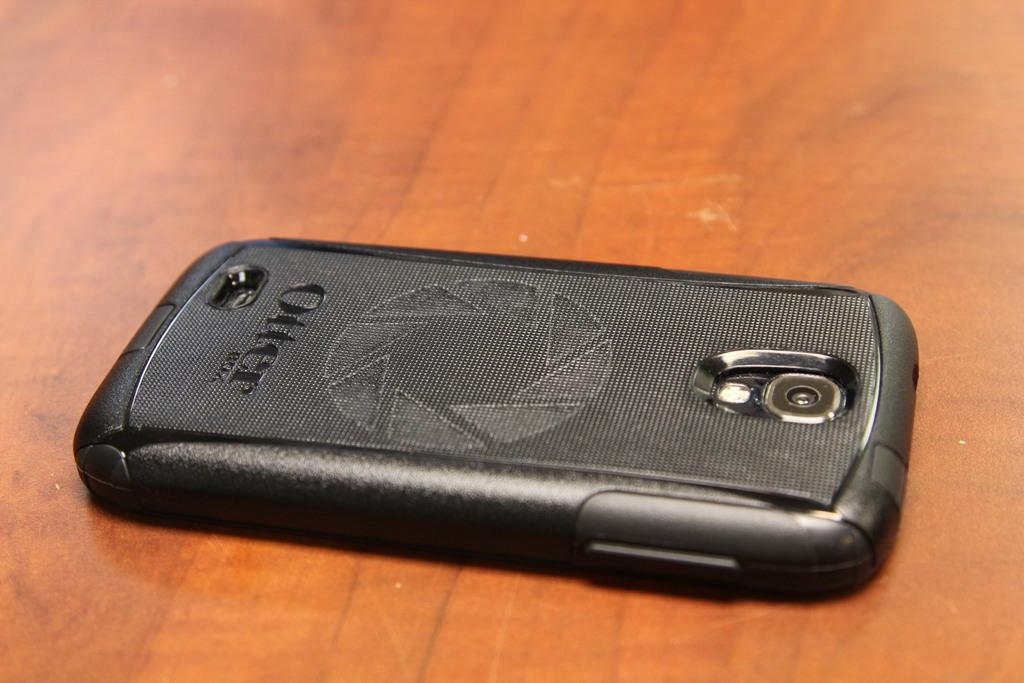<image>
Create a compact narrative representing the image presented. A phone that has a case with the word "Otter" on it. 